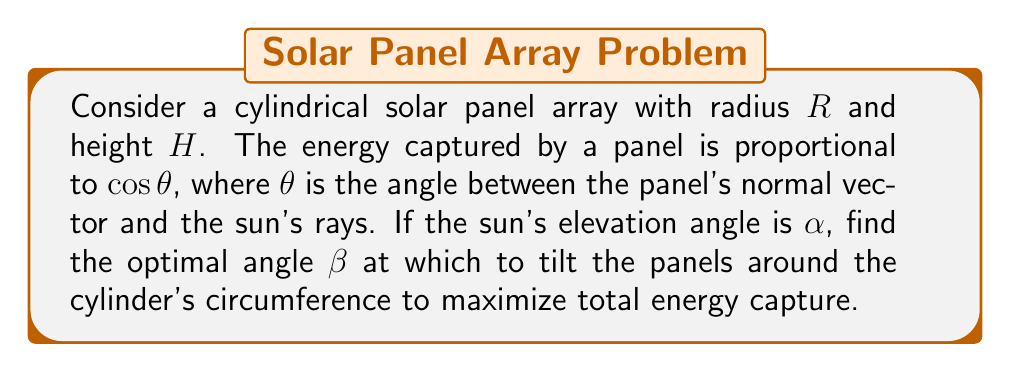Teach me how to tackle this problem. Let's approach this step-by-step:

1) First, we need to express the angle $\theta$ in terms of the known variables. Consider a point on the cylinder at angle $\phi$ from the vertical plane containing the sun:

   $$\cos \theta = \sin \alpha \cos \beta + \cos \alpha \sin \beta \cos \phi$$

2) The total energy captured over the entire cylinder is proportional to the integral:

   $$E \propto \int_0^H \int_0^{2\pi} (\sin \alpha \cos \beta + \cos \alpha \sin \beta \cos \phi) R d\phi dz$$

3) Simplify the integral:

   $$E \propto 2\pi RH (\sin \alpha \cos \beta)$$

   The $\cos \phi$ term integrates to zero over a full revolution.

4) To maximize E, we need to maximize $\sin \alpha \cos \beta$. This occurs when $\beta = 90° - \alpha$.

5) Verify with calculus:

   $$\frac{dE}{d\beta} \propto -\sin \alpha \sin \beta$$

   Setting this to zero: $-\sin \alpha \sin \beta = 0$
   
   For $\sin \alpha \neq 0$, this occurs when $\sin \beta = 0$, or $\beta = 0°$ or $90°$.

6) The second derivative:

   $$\frac{d^2E}{d\beta^2} \propto -\sin \alpha \cos \beta$$

   This is negative when $\beta = 90° - \alpha$, confirming a maximum.

Therefore, the optimal tilt angle $\beta$ is $90° - \alpha$.
Answer: $\beta = 90° - \alpha$ 